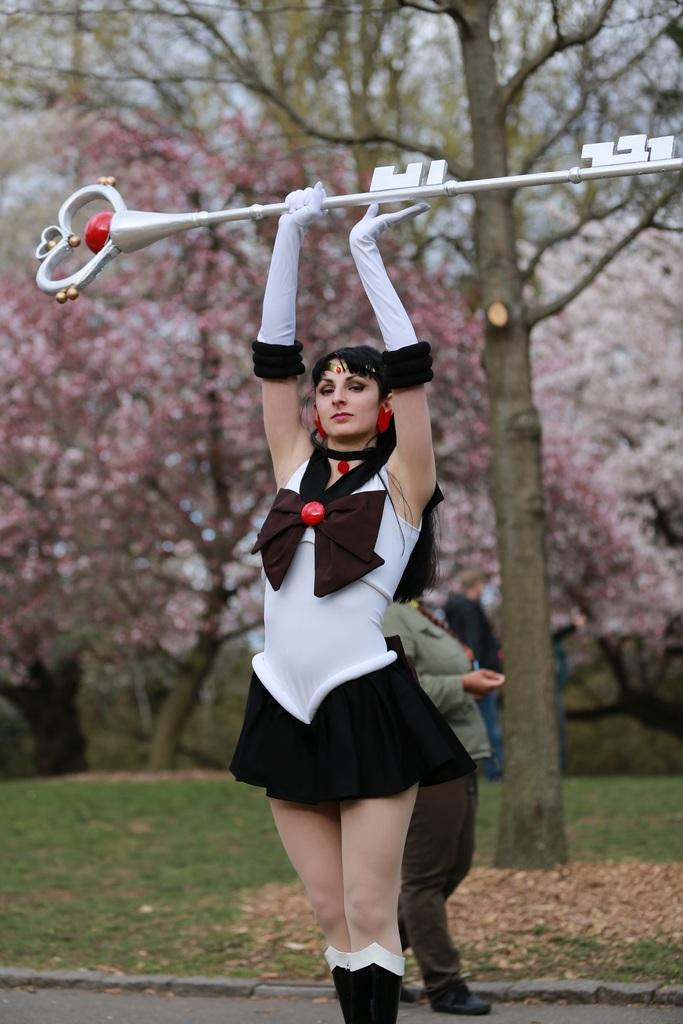What is the woman in the image holding? The woman is holding an object that looks like a key. What is the woman's position in the image? The woman is standing in the image. What is the other person in the image doing? There is a person walking in the image. What type of terrain is visible in the image? There is grass on the ground in the image. What can be seen in the background of the image? There are trees visible in the image. What type of quince is being used as a prop in the image? There is no quince present in the image. What language is being spoken by the people in the image? The image does not provide any information about the language being spoken by the people. 